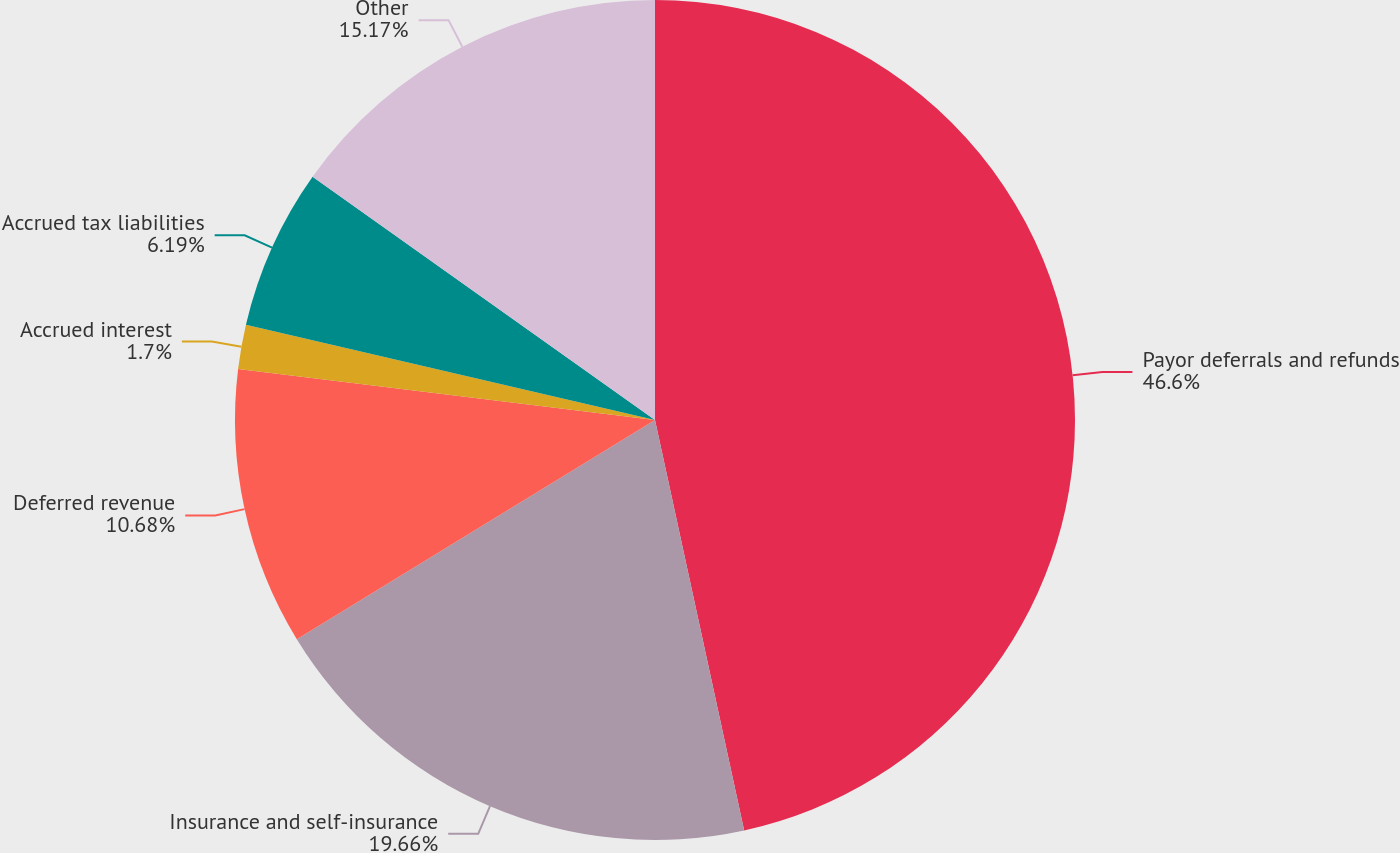Convert chart. <chart><loc_0><loc_0><loc_500><loc_500><pie_chart><fcel>Payor deferrals and refunds<fcel>Insurance and self-insurance<fcel>Deferred revenue<fcel>Accrued interest<fcel>Accrued tax liabilities<fcel>Other<nl><fcel>46.59%<fcel>19.66%<fcel>10.68%<fcel>1.7%<fcel>6.19%<fcel>15.17%<nl></chart> 